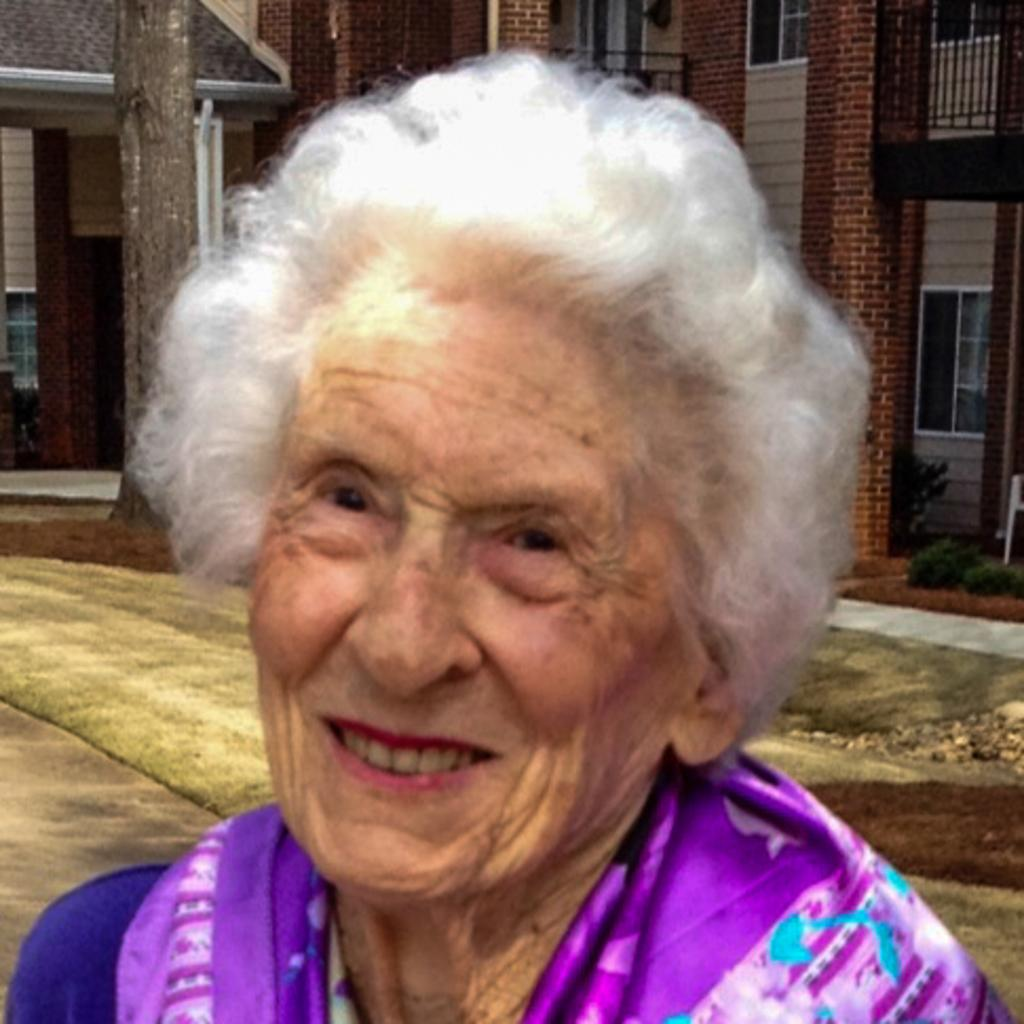Who or what is the main subject in the image? There is a person in the image. Can you describe the person's attire? The person is wearing a blue and purple color dress. What can be seen in the background of the image? There are buildings in the background of the image. What colors are the buildings? The buildings are in brown and cream colors. What type of calculator is the person holding in the image? There is no calculator present in the image. What flavor of jam is on the person's dress in the image? There is no jam on the person's dress in the image. 